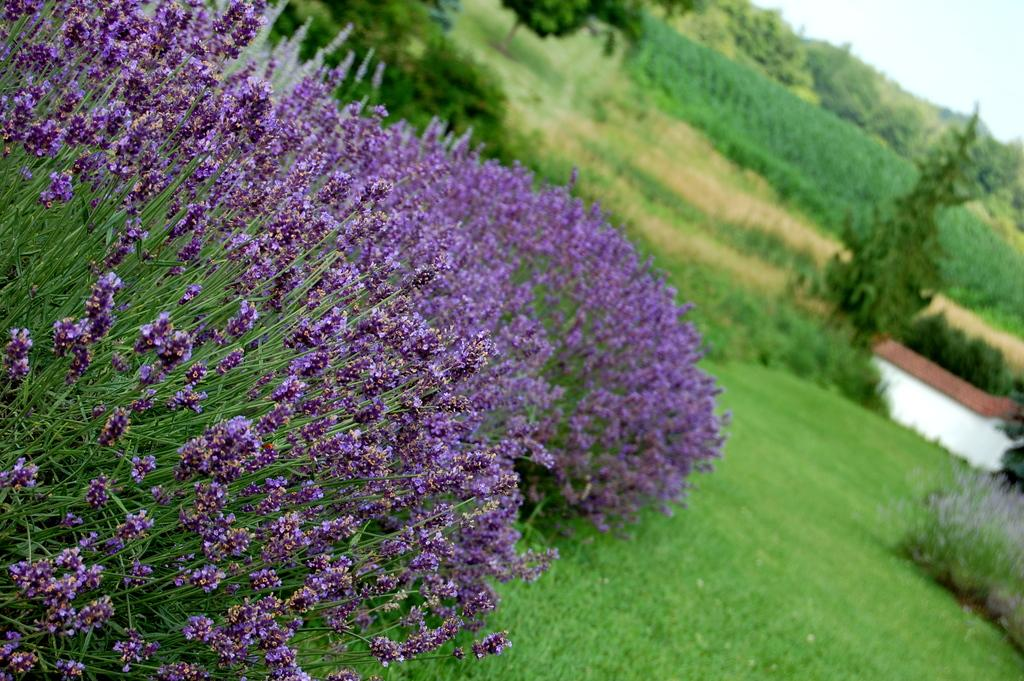What type of vegetation is present in the image? There is grass, plants, and flowers in the image. Can you describe the background of the image? There are trees in the background of the image, and the sky is visible. What might be the purpose of the plants and flowers in the image? The plants and flowers may be for decoration or to attract pollinators. What type of plantation can be seen in the image? There is no plantation present in the image. 